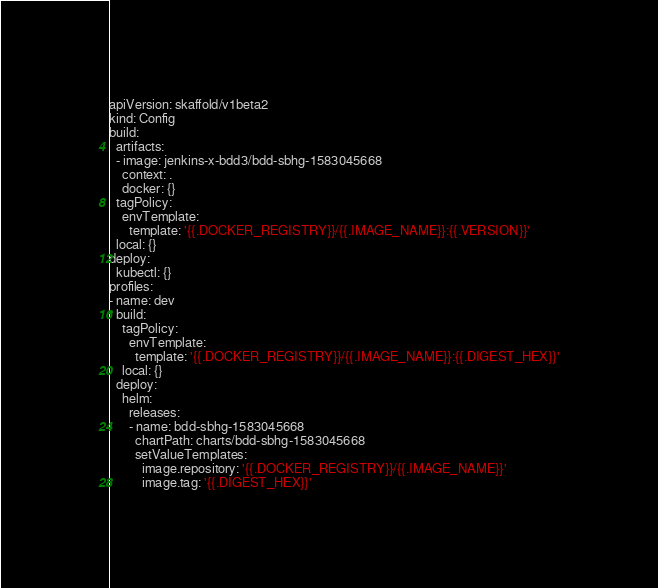<code> <loc_0><loc_0><loc_500><loc_500><_YAML_>apiVersion: skaffold/v1beta2
kind: Config
build:
  artifacts:
  - image: jenkins-x-bdd3/bdd-sbhg-1583045668
    context: .
    docker: {}
  tagPolicy:
    envTemplate:
      template: '{{.DOCKER_REGISTRY}}/{{.IMAGE_NAME}}:{{.VERSION}}'
  local: {}
deploy:
  kubectl: {}
profiles:
- name: dev
  build:
    tagPolicy:
      envTemplate:
        template: '{{.DOCKER_REGISTRY}}/{{.IMAGE_NAME}}:{{.DIGEST_HEX}}'
    local: {}
  deploy:
    helm:
      releases:
      - name: bdd-sbhg-1583045668
        chartPath: charts/bdd-sbhg-1583045668
        setValueTemplates:
          image.repository: '{{.DOCKER_REGISTRY}}/{{.IMAGE_NAME}}'
          image.tag: '{{.DIGEST_HEX}}'
</code> 